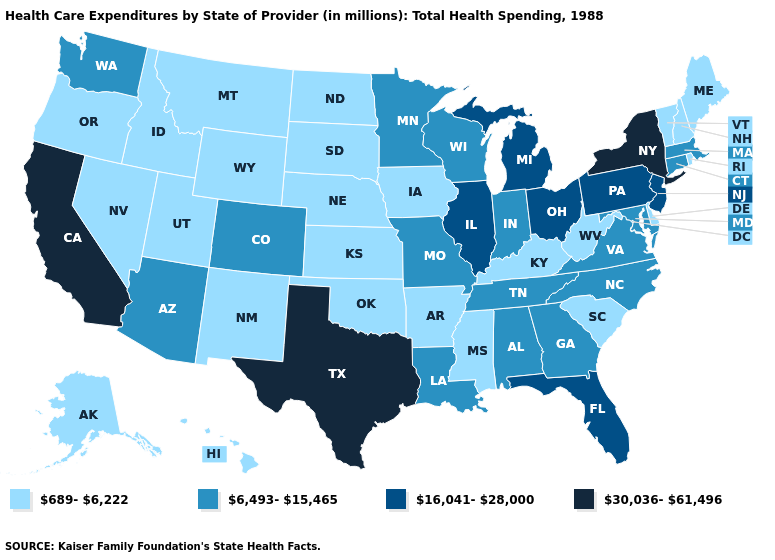Does Louisiana have a higher value than California?
Concise answer only. No. What is the value of Oklahoma?
Write a very short answer. 689-6,222. Name the states that have a value in the range 6,493-15,465?
Concise answer only. Alabama, Arizona, Colorado, Connecticut, Georgia, Indiana, Louisiana, Maryland, Massachusetts, Minnesota, Missouri, North Carolina, Tennessee, Virginia, Washington, Wisconsin. What is the lowest value in the USA?
Write a very short answer. 689-6,222. Does Ohio have a lower value than Idaho?
Quick response, please. No. Name the states that have a value in the range 30,036-61,496?
Write a very short answer. California, New York, Texas. Among the states that border Nevada , which have the lowest value?
Quick response, please. Idaho, Oregon, Utah. Among the states that border Louisiana , does Texas have the highest value?
Write a very short answer. Yes. Name the states that have a value in the range 689-6,222?
Answer briefly. Alaska, Arkansas, Delaware, Hawaii, Idaho, Iowa, Kansas, Kentucky, Maine, Mississippi, Montana, Nebraska, Nevada, New Hampshire, New Mexico, North Dakota, Oklahoma, Oregon, Rhode Island, South Carolina, South Dakota, Utah, Vermont, West Virginia, Wyoming. Name the states that have a value in the range 30,036-61,496?
Give a very brief answer. California, New York, Texas. Does Louisiana have the highest value in the USA?
Give a very brief answer. No. What is the value of Tennessee?
Concise answer only. 6,493-15,465. Does the first symbol in the legend represent the smallest category?
Give a very brief answer. Yes. Name the states that have a value in the range 16,041-28,000?
Give a very brief answer. Florida, Illinois, Michigan, New Jersey, Ohio, Pennsylvania. What is the value of Indiana?
Keep it brief. 6,493-15,465. 